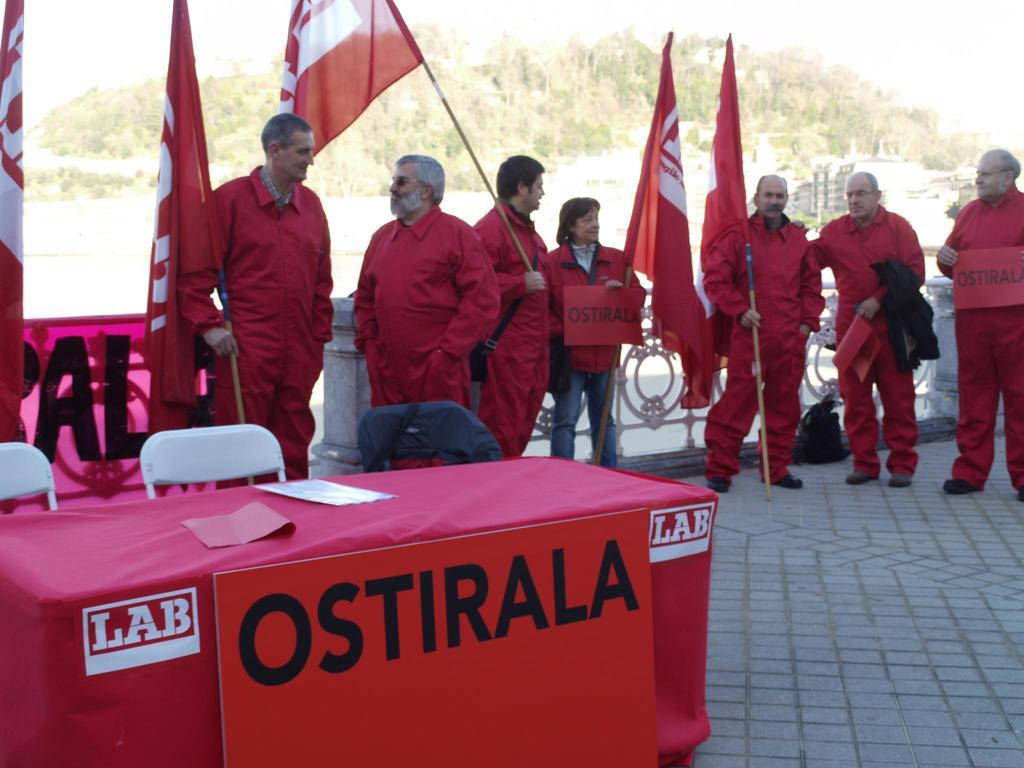What color are the dresses of the persons in the image? The persons in the image are wearing red color dresses. What are the persons holding in their hands? The persons are holding flags in their hands. What furniture can be seen on the left side of the image? There is a table and chairs on the left side of the image. What can be seen in the background of the image? There are trees in the background of the image. Can you tell me how many holes are present in the flags held by the persons in the image? There is no information about holes in the flags held by the persons in the image. 